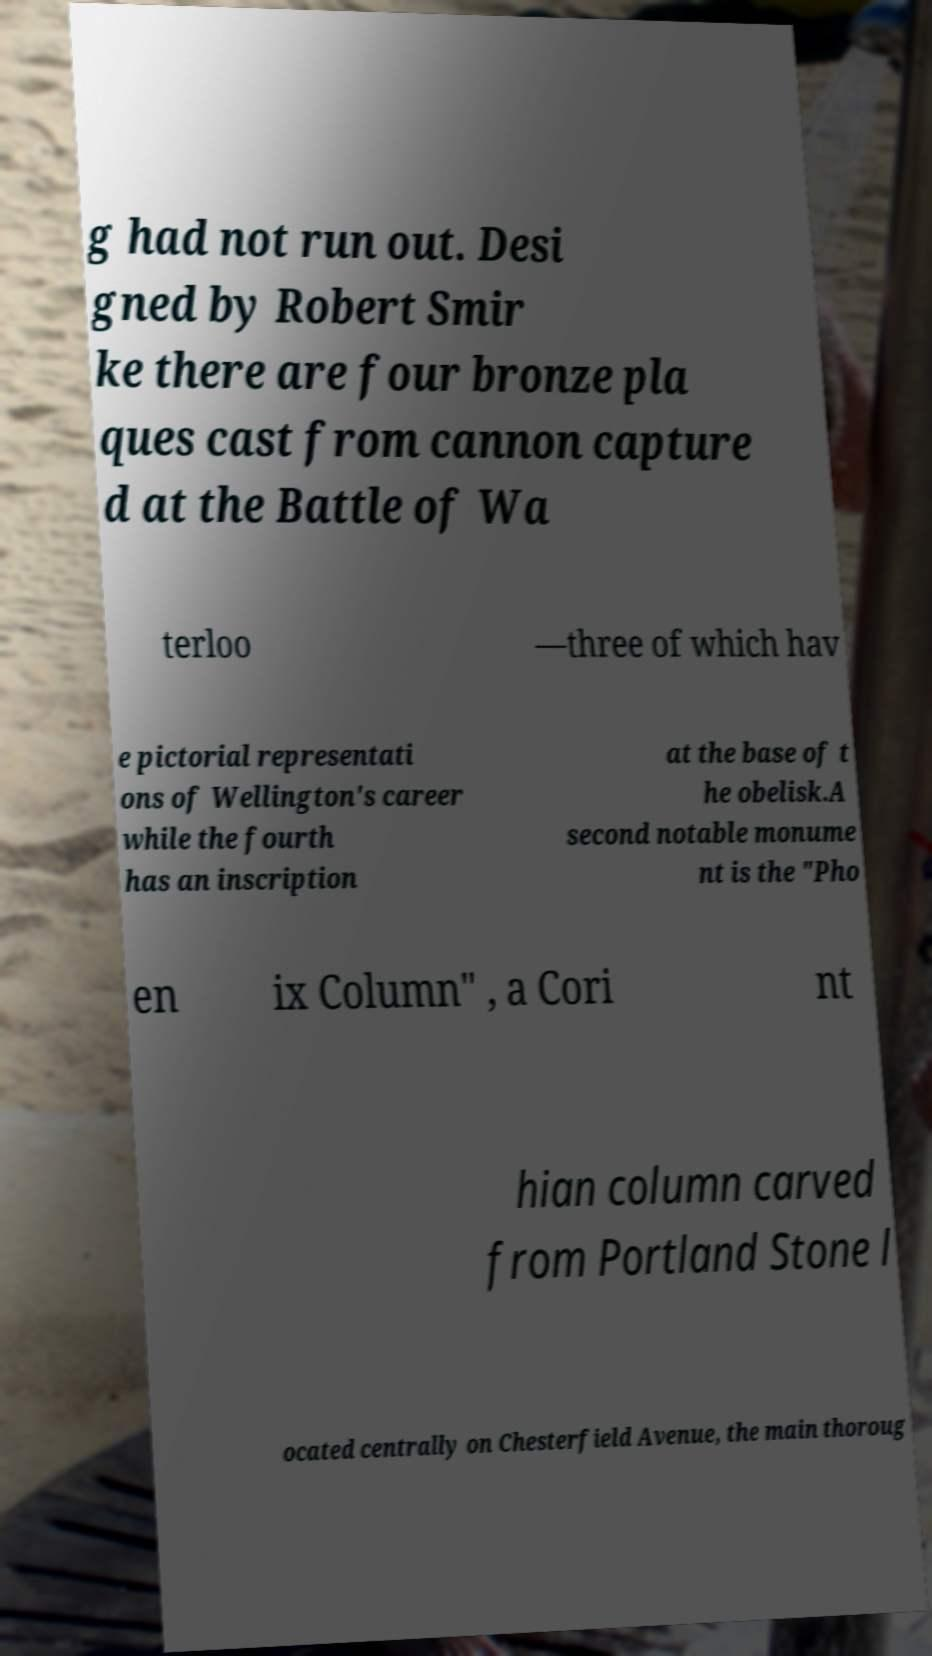I need the written content from this picture converted into text. Can you do that? g had not run out. Desi gned by Robert Smir ke there are four bronze pla ques cast from cannon capture d at the Battle of Wa terloo —three of which hav e pictorial representati ons of Wellington's career while the fourth has an inscription at the base of t he obelisk.A second notable monume nt is the "Pho en ix Column" , a Cori nt hian column carved from Portland Stone l ocated centrally on Chesterfield Avenue, the main thoroug 